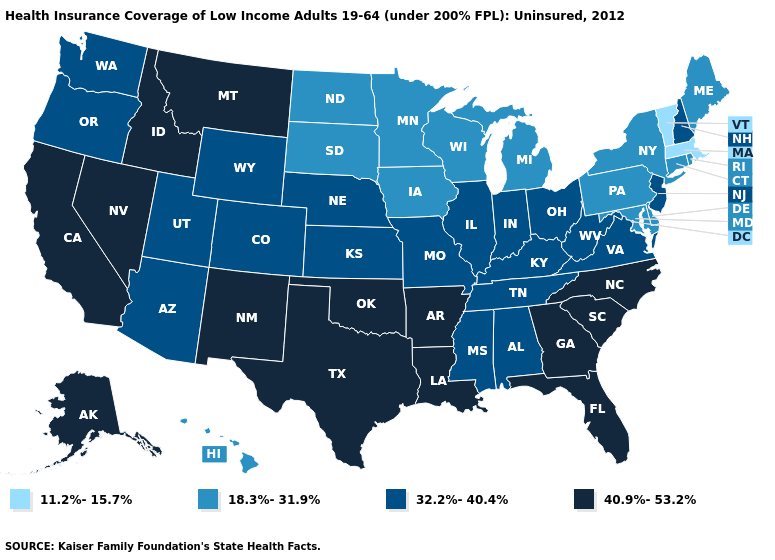What is the value of Florida?
Keep it brief. 40.9%-53.2%. Which states have the lowest value in the West?
Write a very short answer. Hawaii. Name the states that have a value in the range 11.2%-15.7%?
Give a very brief answer. Massachusetts, Vermont. Among the states that border Virginia , which have the highest value?
Concise answer only. North Carolina. What is the value of Washington?
Give a very brief answer. 32.2%-40.4%. Name the states that have a value in the range 18.3%-31.9%?
Quick response, please. Connecticut, Delaware, Hawaii, Iowa, Maine, Maryland, Michigan, Minnesota, New York, North Dakota, Pennsylvania, Rhode Island, South Dakota, Wisconsin. Does the first symbol in the legend represent the smallest category?
Concise answer only. Yes. Which states have the lowest value in the South?
Concise answer only. Delaware, Maryland. Name the states that have a value in the range 32.2%-40.4%?
Write a very short answer. Alabama, Arizona, Colorado, Illinois, Indiana, Kansas, Kentucky, Mississippi, Missouri, Nebraska, New Hampshire, New Jersey, Ohio, Oregon, Tennessee, Utah, Virginia, Washington, West Virginia, Wyoming. Name the states that have a value in the range 32.2%-40.4%?
Give a very brief answer. Alabama, Arizona, Colorado, Illinois, Indiana, Kansas, Kentucky, Mississippi, Missouri, Nebraska, New Hampshire, New Jersey, Ohio, Oregon, Tennessee, Utah, Virginia, Washington, West Virginia, Wyoming. Name the states that have a value in the range 11.2%-15.7%?
Answer briefly. Massachusetts, Vermont. What is the lowest value in states that border New Jersey?
Short answer required. 18.3%-31.9%. Name the states that have a value in the range 18.3%-31.9%?
Write a very short answer. Connecticut, Delaware, Hawaii, Iowa, Maine, Maryland, Michigan, Minnesota, New York, North Dakota, Pennsylvania, Rhode Island, South Dakota, Wisconsin. Name the states that have a value in the range 40.9%-53.2%?
Short answer required. Alaska, Arkansas, California, Florida, Georgia, Idaho, Louisiana, Montana, Nevada, New Mexico, North Carolina, Oklahoma, South Carolina, Texas. Does the map have missing data?
Concise answer only. No. 